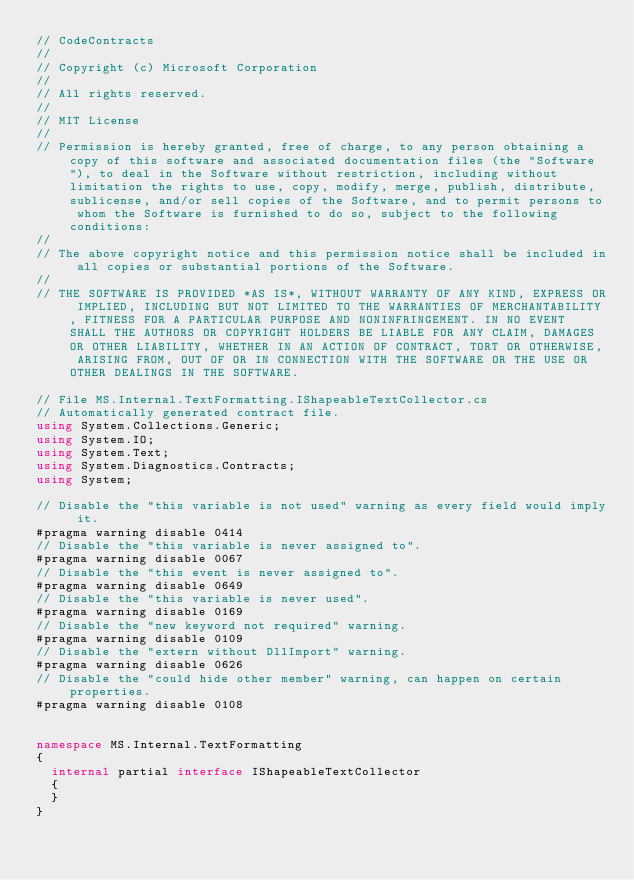Convert code to text. <code><loc_0><loc_0><loc_500><loc_500><_C#_>// CodeContracts
// 
// Copyright (c) Microsoft Corporation
// 
// All rights reserved. 
// 
// MIT License
// 
// Permission is hereby granted, free of charge, to any person obtaining a copy of this software and associated documentation files (the "Software"), to deal in the Software without restriction, including without limitation the rights to use, copy, modify, merge, publish, distribute, sublicense, and/or sell copies of the Software, and to permit persons to whom the Software is furnished to do so, subject to the following conditions:
// 
// The above copyright notice and this permission notice shall be included in all copies or substantial portions of the Software.
// 
// THE SOFTWARE IS PROVIDED *AS IS*, WITHOUT WARRANTY OF ANY KIND, EXPRESS OR IMPLIED, INCLUDING BUT NOT LIMITED TO THE WARRANTIES OF MERCHANTABILITY, FITNESS FOR A PARTICULAR PURPOSE AND NONINFRINGEMENT. IN NO EVENT SHALL THE AUTHORS OR COPYRIGHT HOLDERS BE LIABLE FOR ANY CLAIM, DAMAGES OR OTHER LIABILITY, WHETHER IN AN ACTION OF CONTRACT, TORT OR OTHERWISE, ARISING FROM, OUT OF OR IN CONNECTION WITH THE SOFTWARE OR THE USE OR OTHER DEALINGS IN THE SOFTWARE.

// File MS.Internal.TextFormatting.IShapeableTextCollector.cs
// Automatically generated contract file.
using System.Collections.Generic;
using System.IO;
using System.Text;
using System.Diagnostics.Contracts;
using System;

// Disable the "this variable is not used" warning as every field would imply it.
#pragma warning disable 0414
// Disable the "this variable is never assigned to".
#pragma warning disable 0067
// Disable the "this event is never assigned to".
#pragma warning disable 0649
// Disable the "this variable is never used".
#pragma warning disable 0169
// Disable the "new keyword not required" warning.
#pragma warning disable 0109
// Disable the "extern without DllImport" warning.
#pragma warning disable 0626
// Disable the "could hide other member" warning, can happen on certain properties.
#pragma warning disable 0108


namespace MS.Internal.TextFormatting
{
  internal partial interface IShapeableTextCollector
  {
  }
}
</code> 